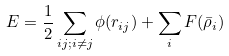Convert formula to latex. <formula><loc_0><loc_0><loc_500><loc_500>E = \frac { 1 } { 2 } \sum _ { i j ; i \ne j } \phi ( r _ { i j } ) + \sum _ { i } F ( \bar { \rho } _ { i } )</formula> 